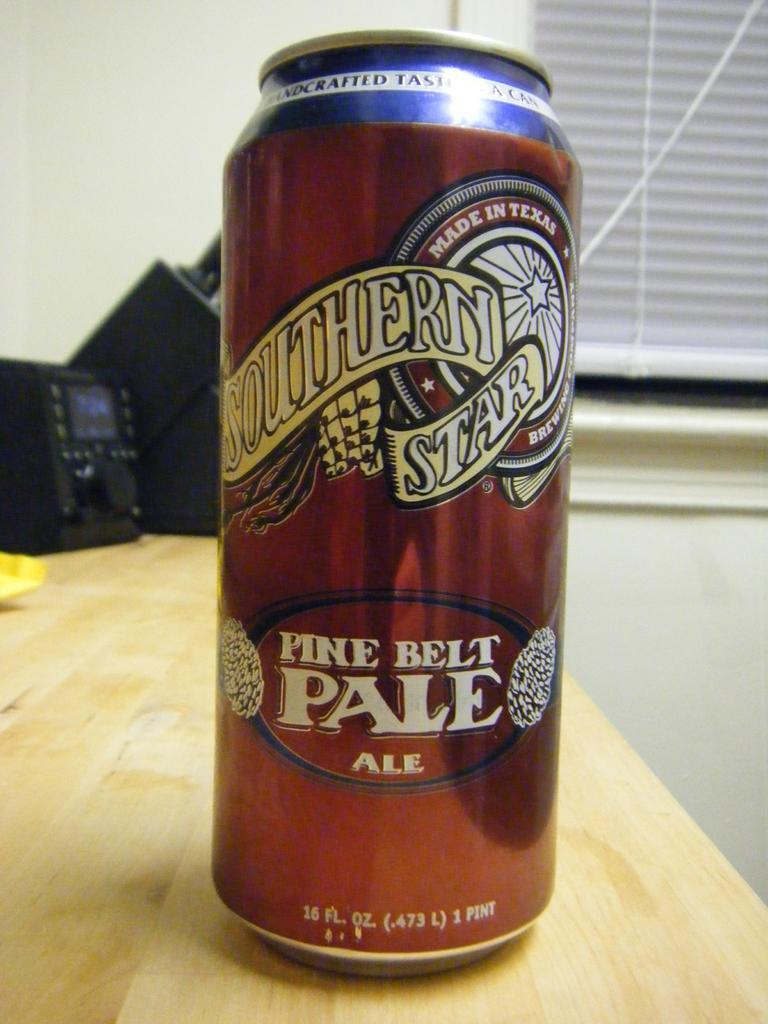<image>
Render a clear and concise summary of the photo. A can of Southern Star Pine Belt Pale Ale has 16 fl. oz. 